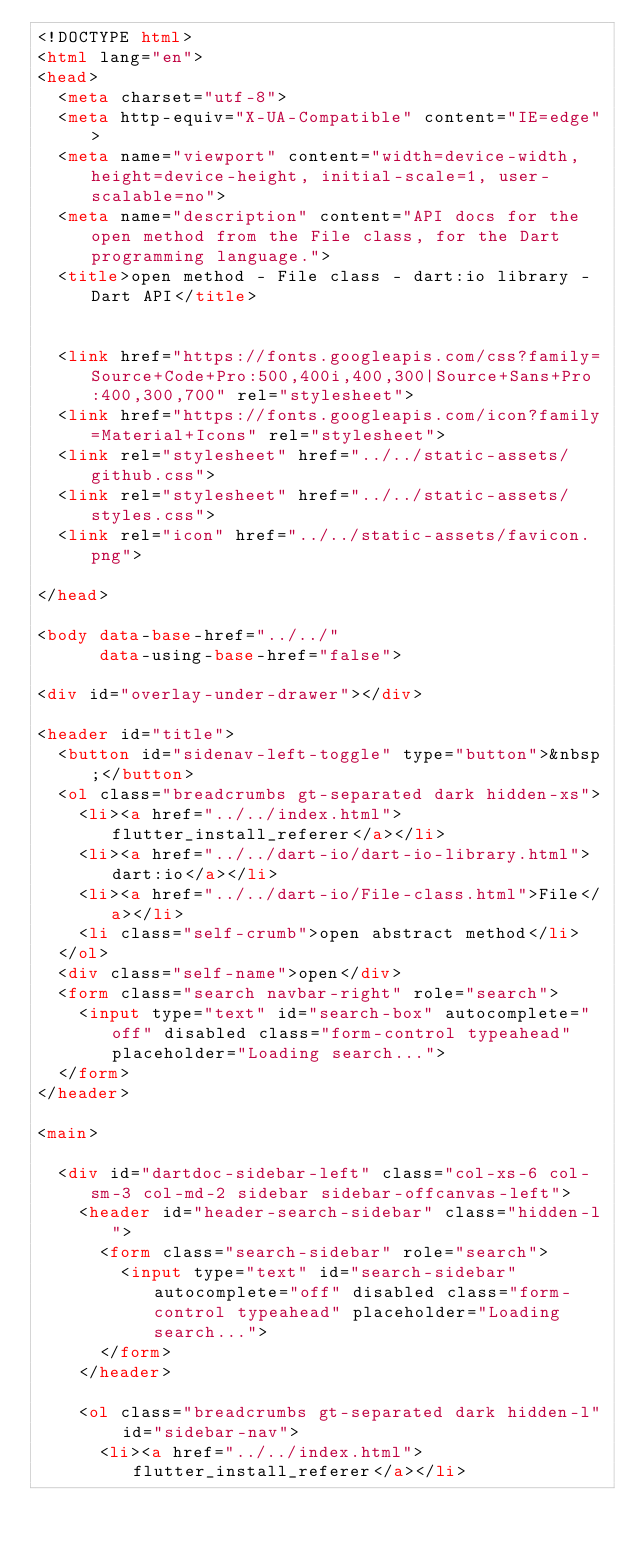Convert code to text. <code><loc_0><loc_0><loc_500><loc_500><_HTML_><!DOCTYPE html>
<html lang="en">
<head>
  <meta charset="utf-8">
  <meta http-equiv="X-UA-Compatible" content="IE=edge">
  <meta name="viewport" content="width=device-width, height=device-height, initial-scale=1, user-scalable=no">
  <meta name="description" content="API docs for the open method from the File class, for the Dart programming language.">
  <title>open method - File class - dart:io library - Dart API</title>

  
  <link href="https://fonts.googleapis.com/css?family=Source+Code+Pro:500,400i,400,300|Source+Sans+Pro:400,300,700" rel="stylesheet">
  <link href="https://fonts.googleapis.com/icon?family=Material+Icons" rel="stylesheet">
  <link rel="stylesheet" href="../../static-assets/github.css">
  <link rel="stylesheet" href="../../static-assets/styles.css">
  <link rel="icon" href="../../static-assets/favicon.png">

</head>

<body data-base-href="../../"
      data-using-base-href="false">

<div id="overlay-under-drawer"></div>

<header id="title">
  <button id="sidenav-left-toggle" type="button">&nbsp;</button>
  <ol class="breadcrumbs gt-separated dark hidden-xs">
    <li><a href="../../index.html">flutter_install_referer</a></li>
    <li><a href="../../dart-io/dart-io-library.html">dart:io</a></li>
    <li><a href="../../dart-io/File-class.html">File</a></li>
    <li class="self-crumb">open abstract method</li>
  </ol>
  <div class="self-name">open</div>
  <form class="search navbar-right" role="search">
    <input type="text" id="search-box" autocomplete="off" disabled class="form-control typeahead" placeholder="Loading search...">
  </form>
</header>

<main>

  <div id="dartdoc-sidebar-left" class="col-xs-6 col-sm-3 col-md-2 sidebar sidebar-offcanvas-left">
    <header id="header-search-sidebar" class="hidden-l">
      <form class="search-sidebar" role="search">
        <input type="text" id="search-sidebar" autocomplete="off" disabled class="form-control typeahead" placeholder="Loading search...">
      </form>
    </header>
    
    <ol class="breadcrumbs gt-separated dark hidden-l" id="sidebar-nav">
      <li><a href="../../index.html">flutter_install_referer</a></li></code> 